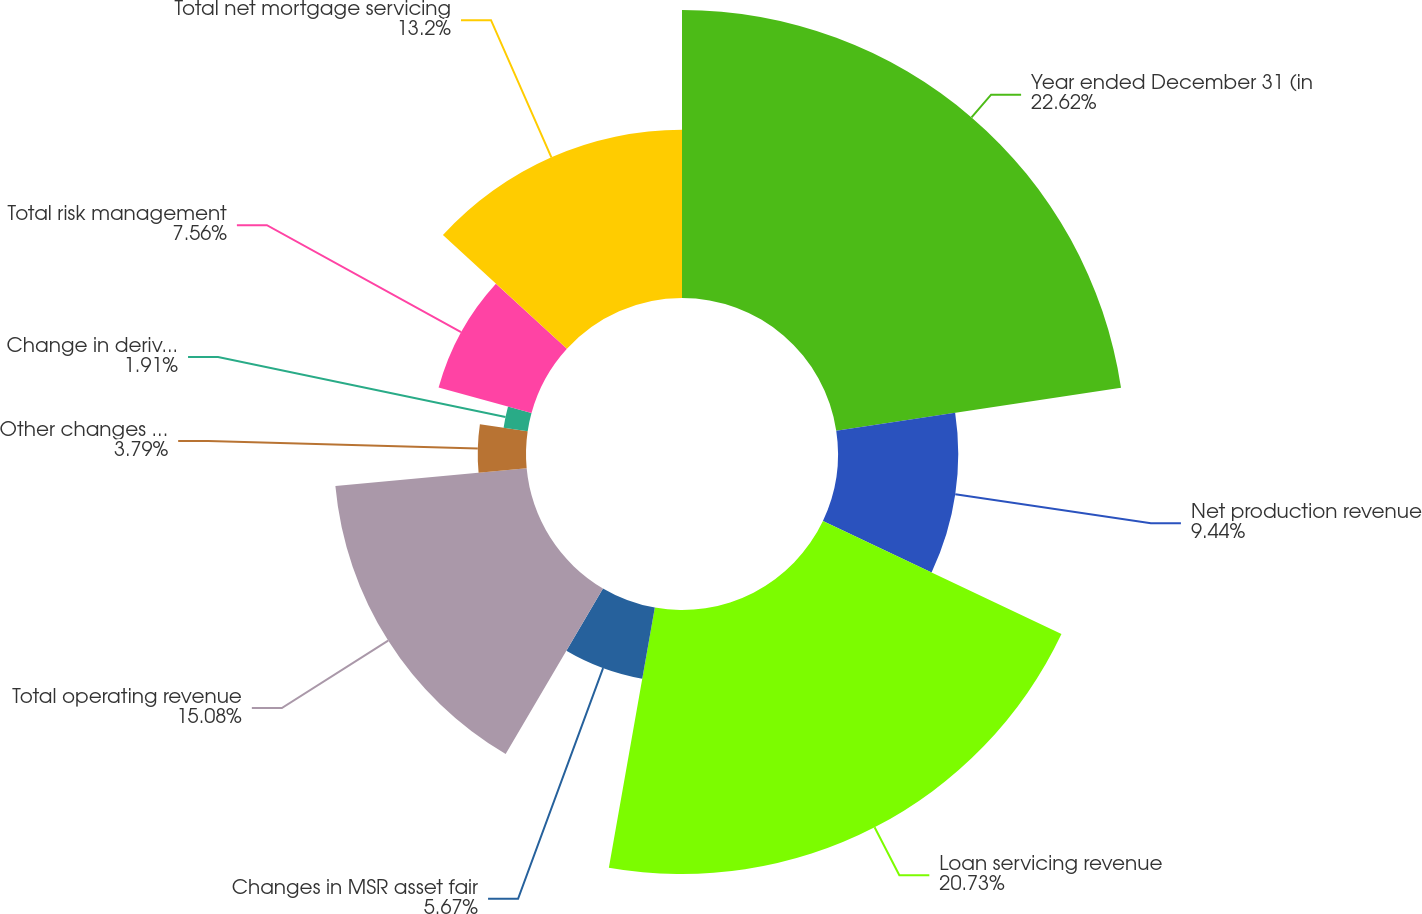Convert chart to OTSL. <chart><loc_0><loc_0><loc_500><loc_500><pie_chart><fcel>Year ended December 31 (in<fcel>Net production revenue<fcel>Loan servicing revenue<fcel>Changes in MSR asset fair<fcel>Total operating revenue<fcel>Other changes in MSR asset<fcel>Change in derivative fair<fcel>Total risk management<fcel>Total net mortgage servicing<nl><fcel>22.61%<fcel>9.44%<fcel>20.73%<fcel>5.67%<fcel>15.08%<fcel>3.79%<fcel>1.91%<fcel>7.56%<fcel>13.2%<nl></chart> 